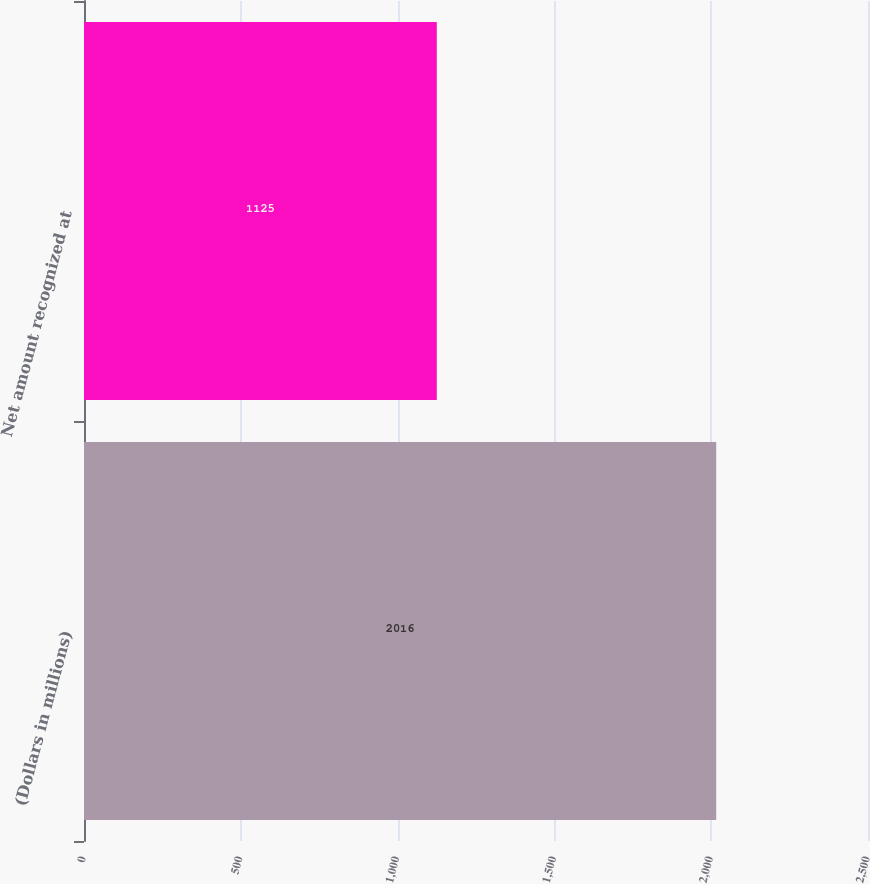<chart> <loc_0><loc_0><loc_500><loc_500><bar_chart><fcel>(Dollars in millions)<fcel>Net amount recognized at<nl><fcel>2016<fcel>1125<nl></chart> 